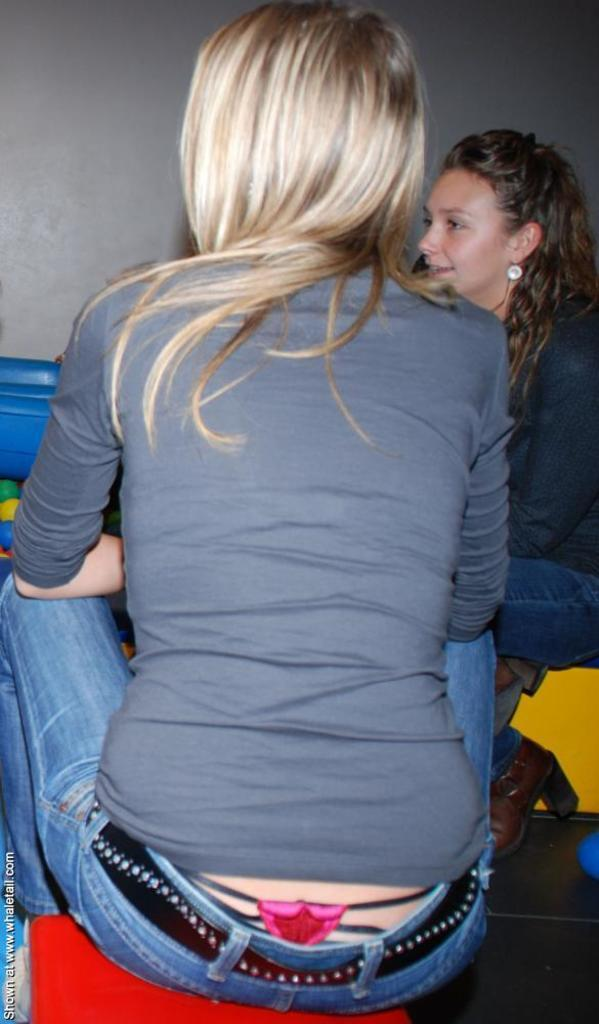How many women are present in the image? There are two women in the image. What are the women doing in the image? The women are sitting on a platform. Where is the platform located? The platform is on the floor. What can be seen in the background of the image? There is a wall and other objects visible in the background. Can you see the ocean in the background of the image? No, the ocean is not visible in the image. Is there a tooth present in the image? No, there is no tooth present in the image. 